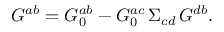<formula> <loc_0><loc_0><loc_500><loc_500>G ^ { a b } = G _ { 0 } ^ { a b } - G _ { 0 } ^ { a c } \, \Sigma _ { c d } \, G ^ { d b } .</formula> 